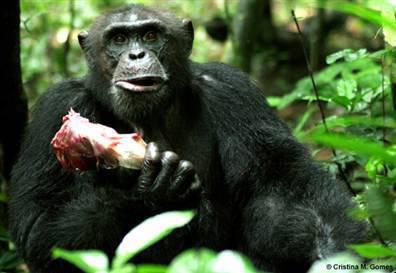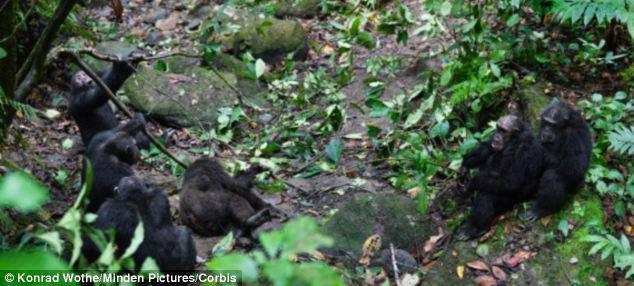The first image is the image on the left, the second image is the image on the right. Given the left and right images, does the statement "there is a single chimp holding animal parts" hold true? Answer yes or no. Yes. The first image is the image on the left, the second image is the image on the right. For the images shown, is this caption "In one image there is a lone chimpanzee eating meat in the center of the image." true? Answer yes or no. Yes. 